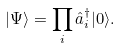<formula> <loc_0><loc_0><loc_500><loc_500>| \Psi \rangle = \prod _ { i } \hat { a } ^ { \dagger } _ { i } | 0 \rangle .</formula> 